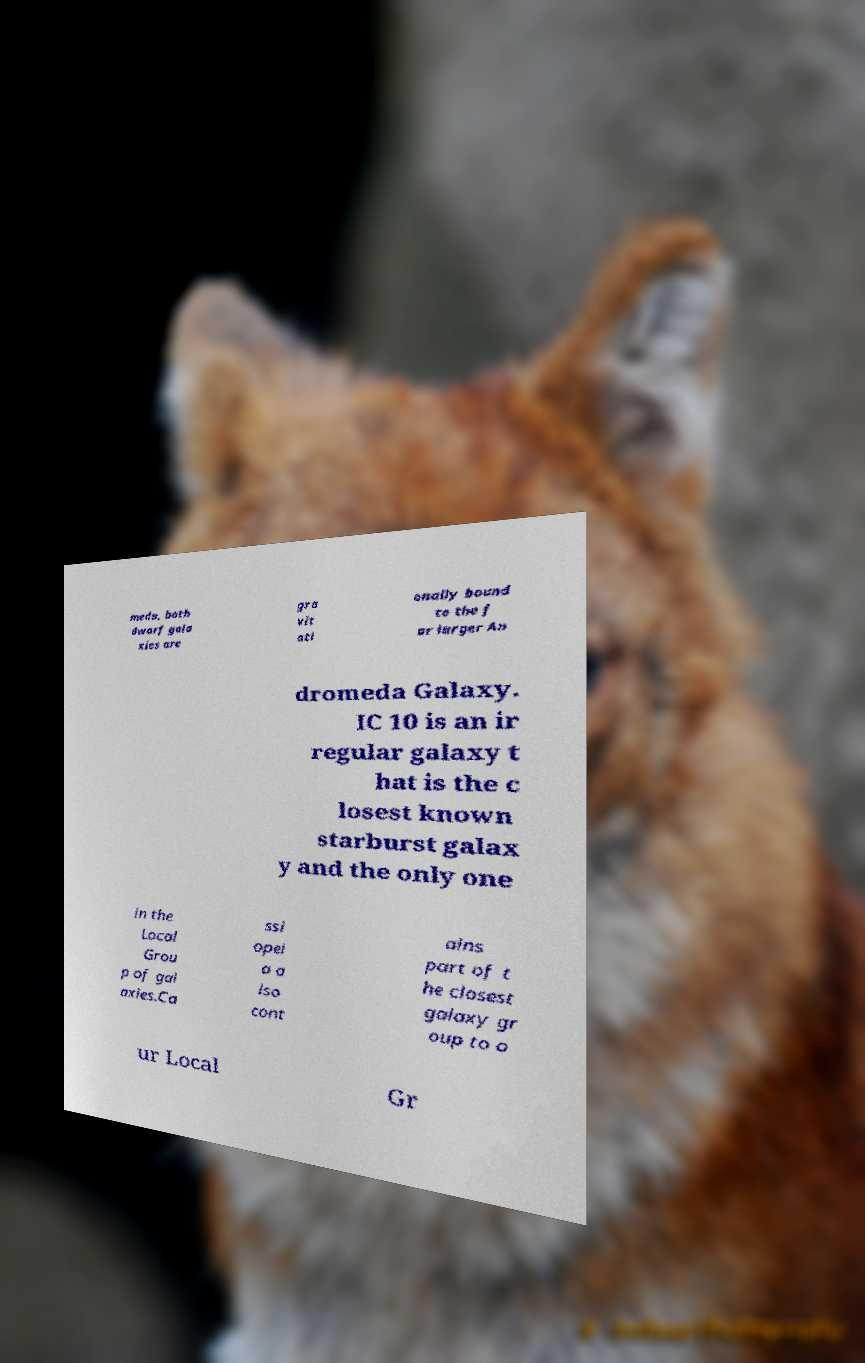For documentation purposes, I need the text within this image transcribed. Could you provide that? meda, both dwarf gala xies are gra vit ati onally bound to the f ar larger An dromeda Galaxy. IC 10 is an ir regular galaxy t hat is the c losest known starburst galax y and the only one in the Local Grou p of gal axies.Ca ssi opei a a lso cont ains part of t he closest galaxy gr oup to o ur Local Gr 